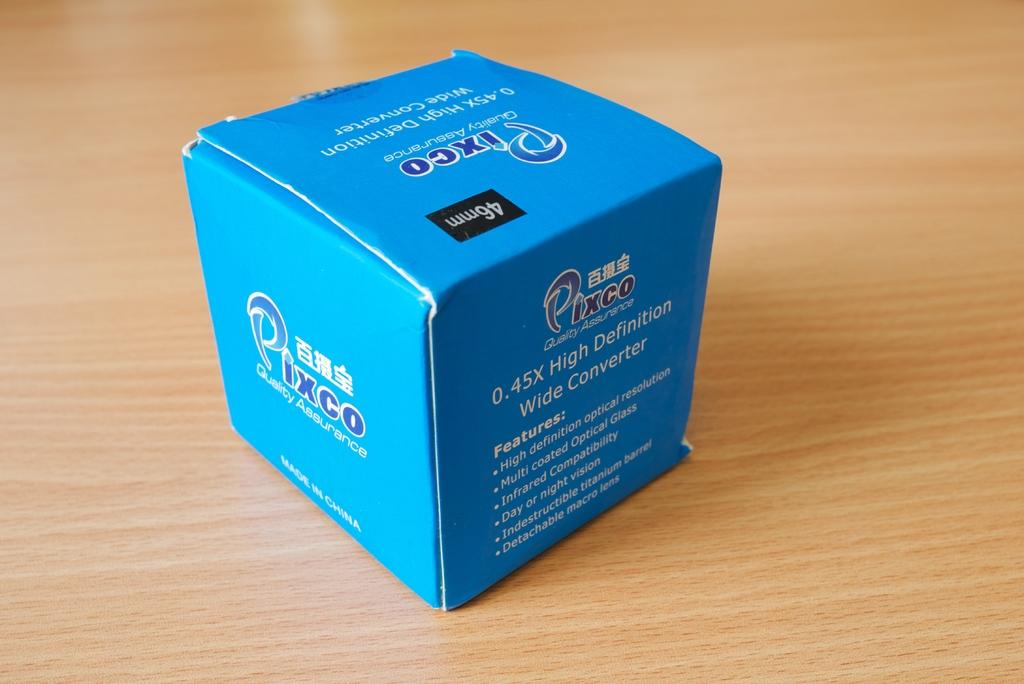<image>
Share a concise interpretation of the image provided. a small blue box on a counter that says 'pixco' on it 